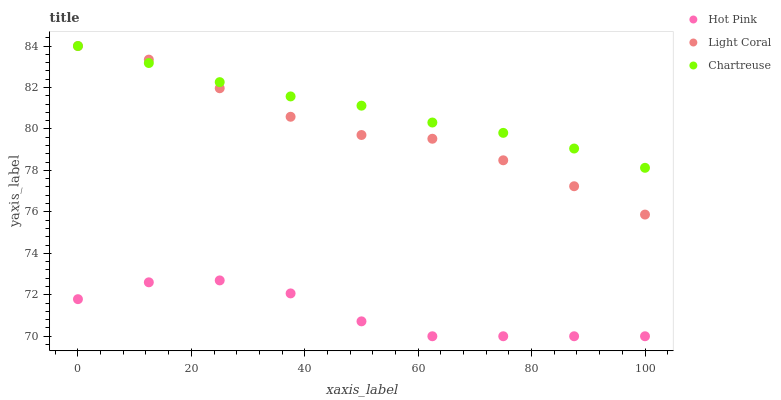Does Hot Pink have the minimum area under the curve?
Answer yes or no. Yes. Does Chartreuse have the maximum area under the curve?
Answer yes or no. Yes. Does Chartreuse have the minimum area under the curve?
Answer yes or no. No. Does Hot Pink have the maximum area under the curve?
Answer yes or no. No. Is Chartreuse the smoothest?
Answer yes or no. Yes. Is Hot Pink the roughest?
Answer yes or no. Yes. Is Hot Pink the smoothest?
Answer yes or no. No. Is Chartreuse the roughest?
Answer yes or no. No. Does Hot Pink have the lowest value?
Answer yes or no. Yes. Does Chartreuse have the lowest value?
Answer yes or no. No. Does Chartreuse have the highest value?
Answer yes or no. Yes. Does Hot Pink have the highest value?
Answer yes or no. No. Is Hot Pink less than Light Coral?
Answer yes or no. Yes. Is Light Coral greater than Hot Pink?
Answer yes or no. Yes. Does Light Coral intersect Chartreuse?
Answer yes or no. Yes. Is Light Coral less than Chartreuse?
Answer yes or no. No. Is Light Coral greater than Chartreuse?
Answer yes or no. No. Does Hot Pink intersect Light Coral?
Answer yes or no. No. 